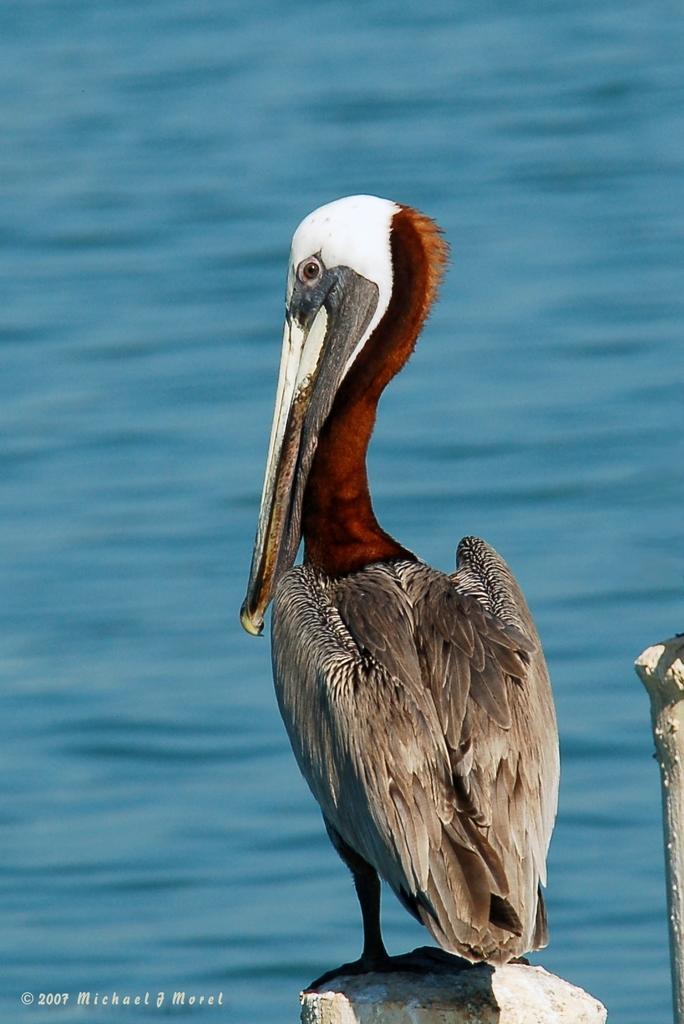In one or two sentences, can you explain what this image depicts? In the picture I can see bird. And behind the picture i can see water. 